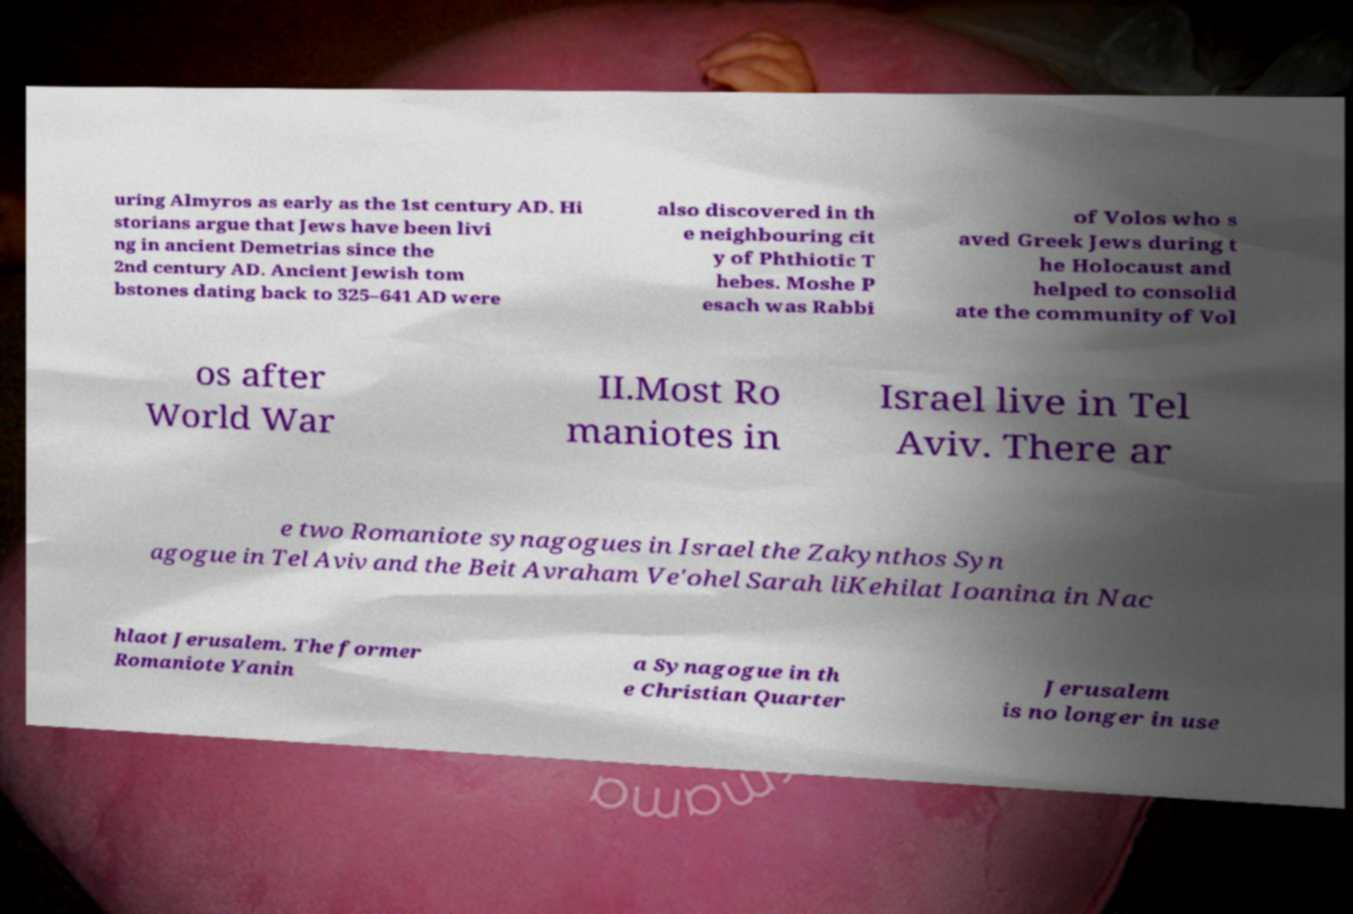There's text embedded in this image that I need extracted. Can you transcribe it verbatim? uring Almyros as early as the 1st century AD. Hi storians argue that Jews have been livi ng in ancient Demetrias since the 2nd century AD. Ancient Jewish tom bstones dating back to 325–641 AD were also discovered in th e neighbouring cit y of Phthiotic T hebes. Moshe P esach was Rabbi of Volos who s aved Greek Jews during t he Holocaust and helped to consolid ate the community of Vol os after World War II.Most Ro maniotes in Israel live in Tel Aviv. There ar e two Romaniote synagogues in Israel the Zakynthos Syn agogue in Tel Aviv and the Beit Avraham Ve'ohel Sarah liKehilat Ioanina in Nac hlaot Jerusalem. The former Romaniote Yanin a Synagogue in th e Christian Quarter Jerusalem is no longer in use 